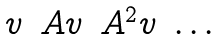<formula> <loc_0><loc_0><loc_500><loc_500>\begin{matrix} v & A v & A ^ { 2 } v & \dots \end{matrix}</formula> 